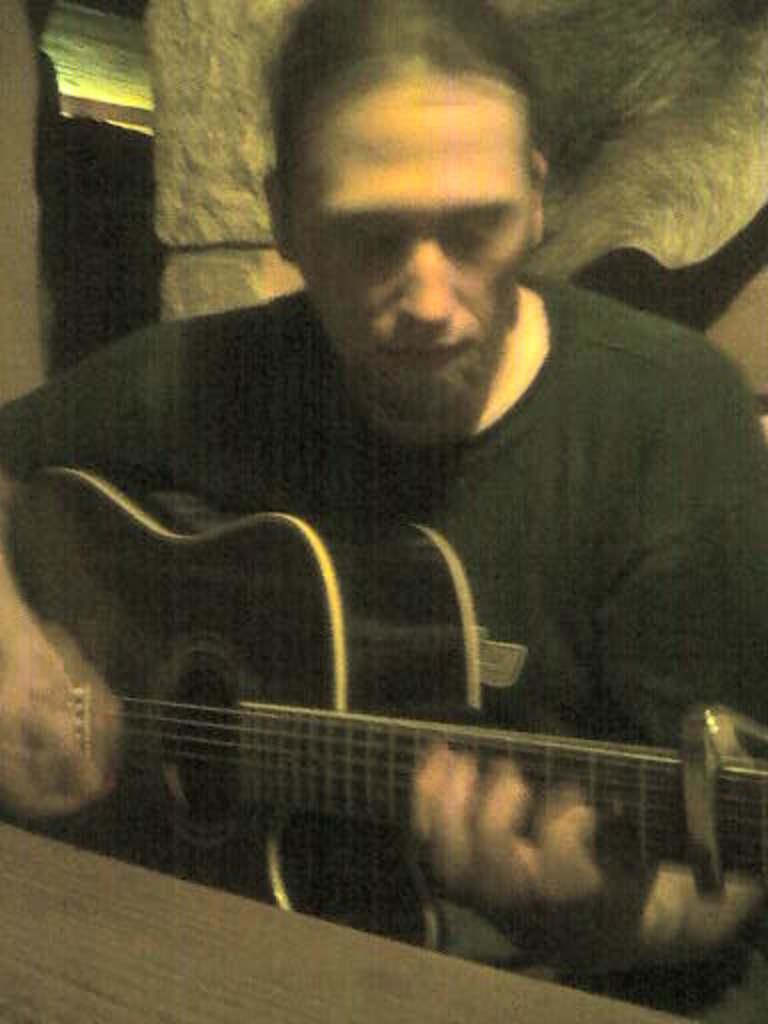What is the main subject of the image? There is a man in the image. What is the man doing in the image? The man is sitting on a chair and playing the guitar. What object is the man holding in the image? The man is holding a guitar. Where is the guitar placed in relation to the table? The guitar is in front of a table. What color is the wall in the background of the image? The wall in the background of the image is white. What type of soup is the man eating in the image? There is no soup present in the image; the man is playing a guitar. What degree does the man have in the image? There is no indication of the man's educational background or degree in the image. 